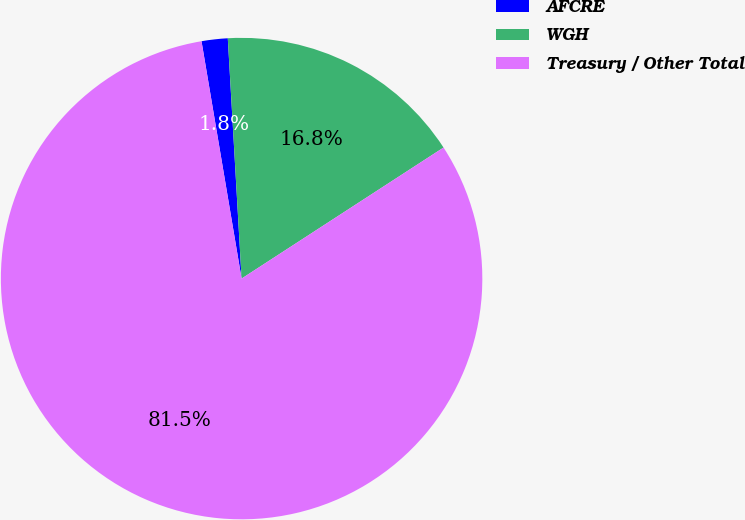<chart> <loc_0><loc_0><loc_500><loc_500><pie_chart><fcel>AFCRE<fcel>WGH<fcel>Treasury / Other Total<nl><fcel>1.75%<fcel>16.75%<fcel>81.49%<nl></chart> 